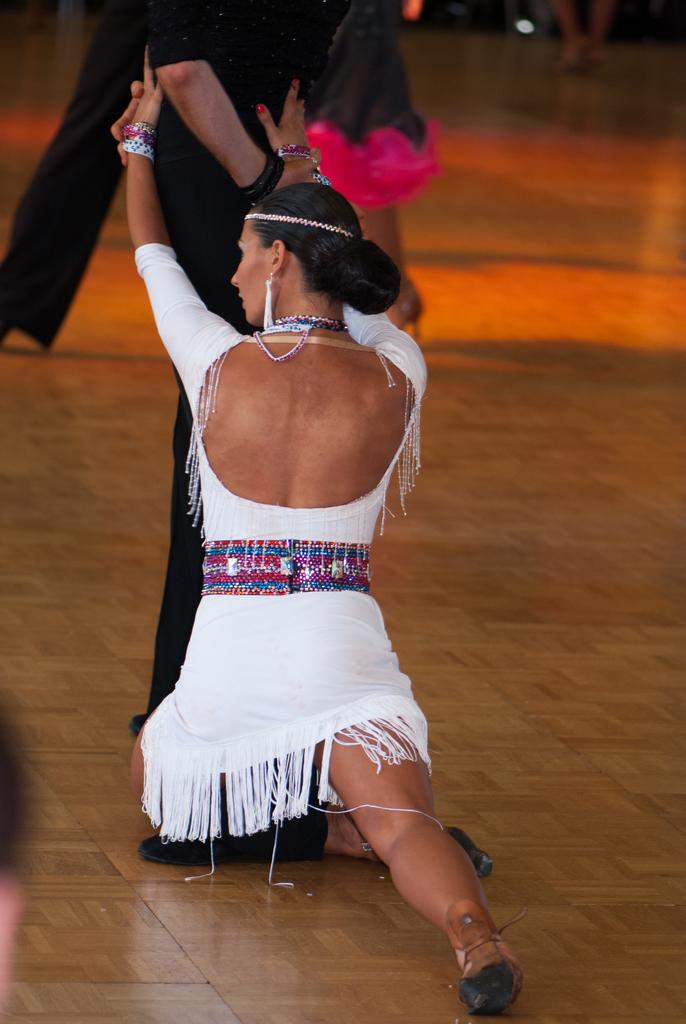What is happening in the image involving a group of people? The people are performing a dance in the image. Where is the dance taking place? The dance is taking place on the floor. What can be seen in the image that provides illumination? There are lights visible in the image. Can you describe the possible location of the image based on the provided facts? The image may have been taken in a hall, given the presence of a group of people performing a dance and the presence of lights. Can you hear the rabbit making quiet noises in the image? There is no rabbit present in the image, and therefore no such sounds can be heard. 